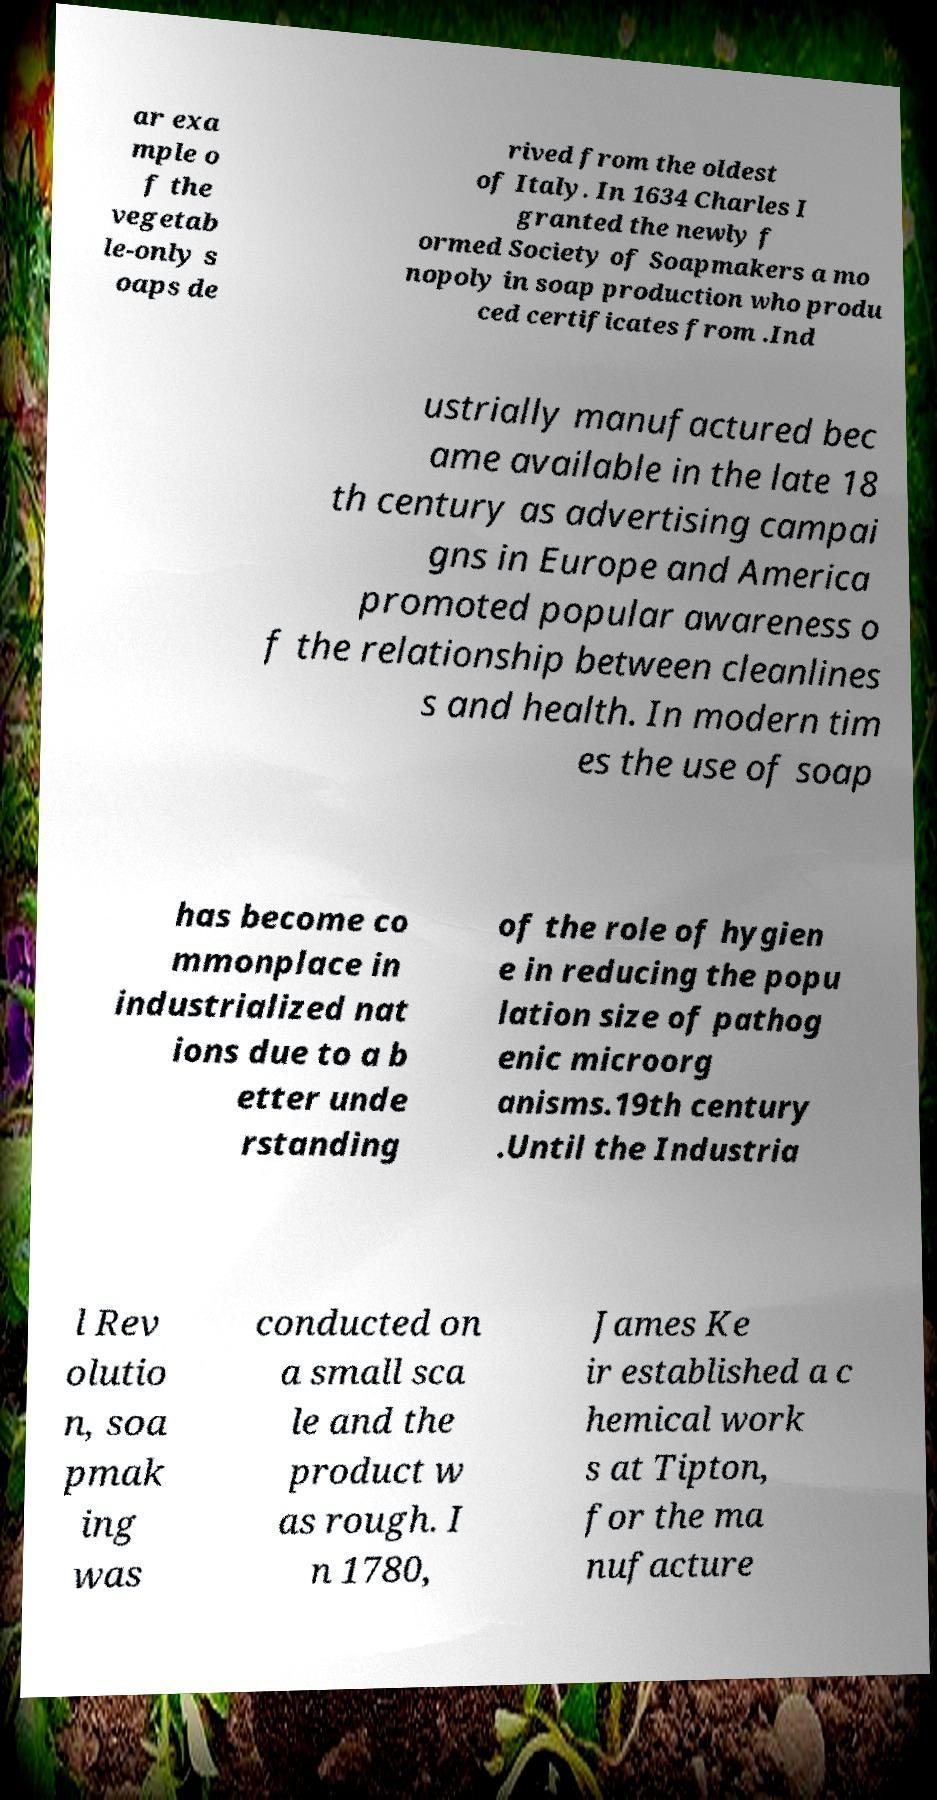What messages or text are displayed in this image? I need them in a readable, typed format. ar exa mple o f the vegetab le-only s oaps de rived from the oldest of Italy. In 1634 Charles I granted the newly f ormed Society of Soapmakers a mo nopoly in soap production who produ ced certificates from .Ind ustrially manufactured bec ame available in the late 18 th century as advertising campai gns in Europe and America promoted popular awareness o f the relationship between cleanlines s and health. In modern tim es the use of soap has become co mmonplace in industrialized nat ions due to a b etter unde rstanding of the role of hygien e in reducing the popu lation size of pathog enic microorg anisms.19th century .Until the Industria l Rev olutio n, soa pmak ing was conducted on a small sca le and the product w as rough. I n 1780, James Ke ir established a c hemical work s at Tipton, for the ma nufacture 